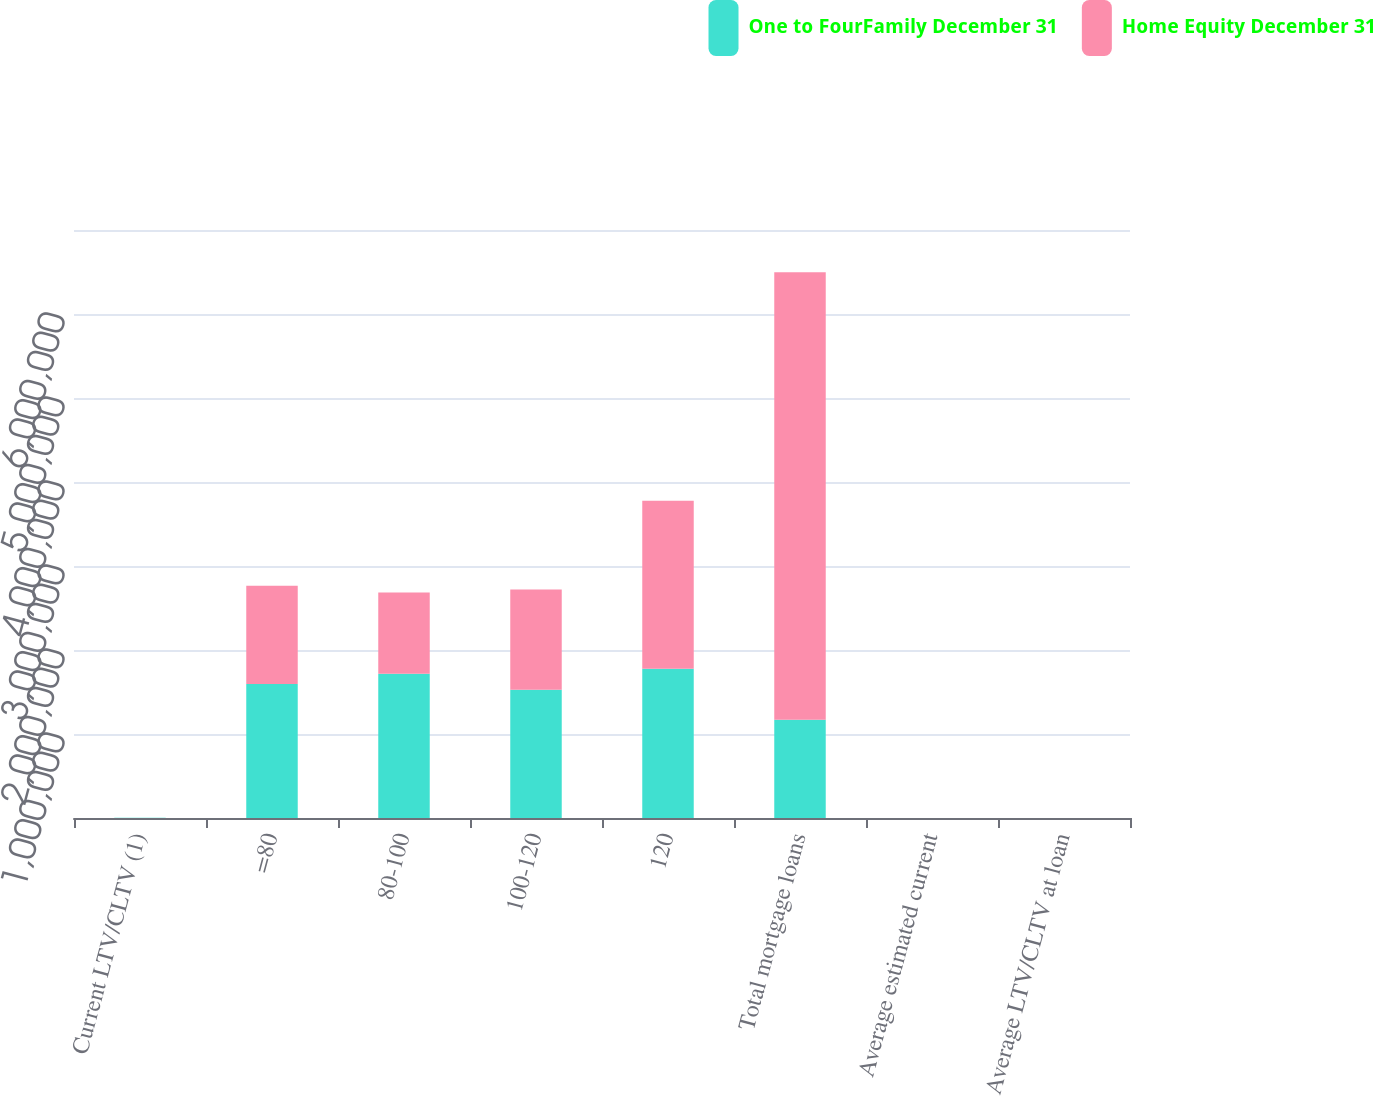Convert chart. <chart><loc_0><loc_0><loc_500><loc_500><stacked_bar_chart><ecel><fcel>Current LTV/CLTV (1)<fcel>=80<fcel>80-100<fcel>100-120<fcel>120<fcel>Total mortgage loans<fcel>Average estimated current<fcel>Average LTV/CLTV at loan<nl><fcel>One to FourFamily December 31<fcel>2011<fcel>1.5963e+06<fcel>1.7168e+06<fcel>1.52727e+06<fcel>1.77544e+06<fcel>1.16885e+06<fcel>106.7<fcel>71<nl><fcel>Home Equity December 31<fcel>2011<fcel>1.16885e+06<fcel>967945<fcel>1.19186e+06<fcel>2e+06<fcel>5.32866e+06<fcel>112.1<fcel>79.2<nl></chart> 